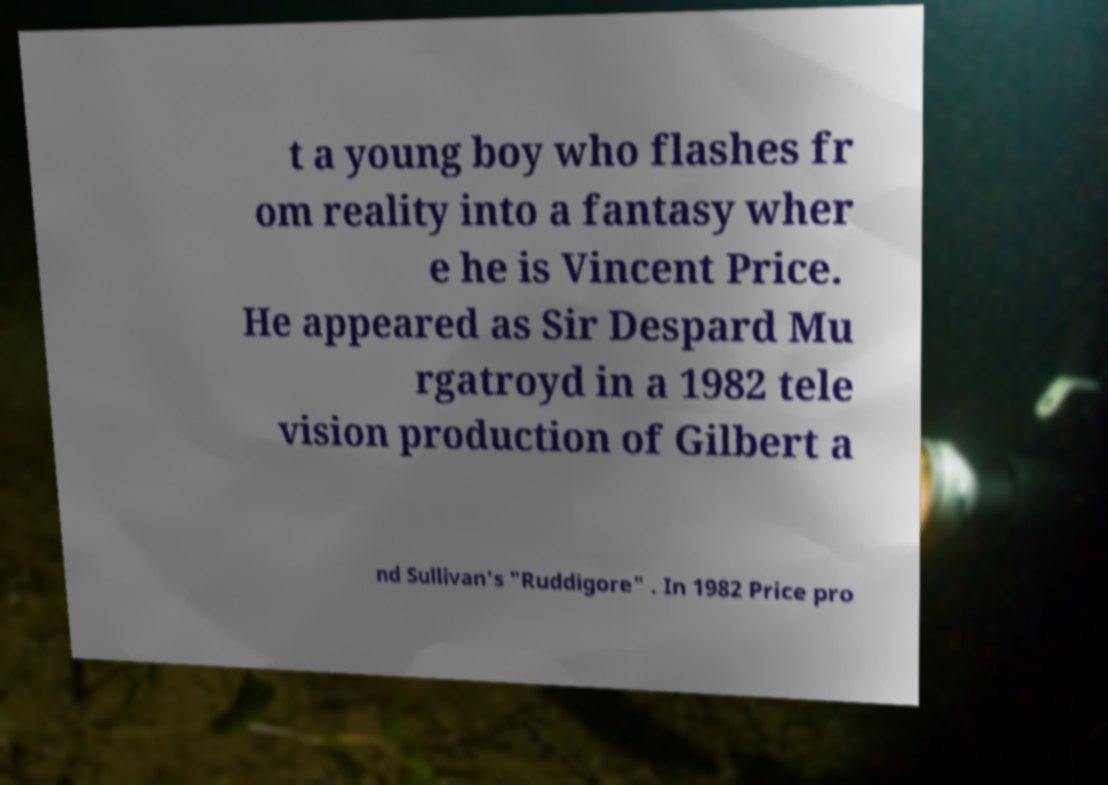I need the written content from this picture converted into text. Can you do that? t a young boy who flashes fr om reality into a fantasy wher e he is Vincent Price. He appeared as Sir Despard Mu rgatroyd in a 1982 tele vision production of Gilbert a nd Sullivan's "Ruddigore" . In 1982 Price pro 